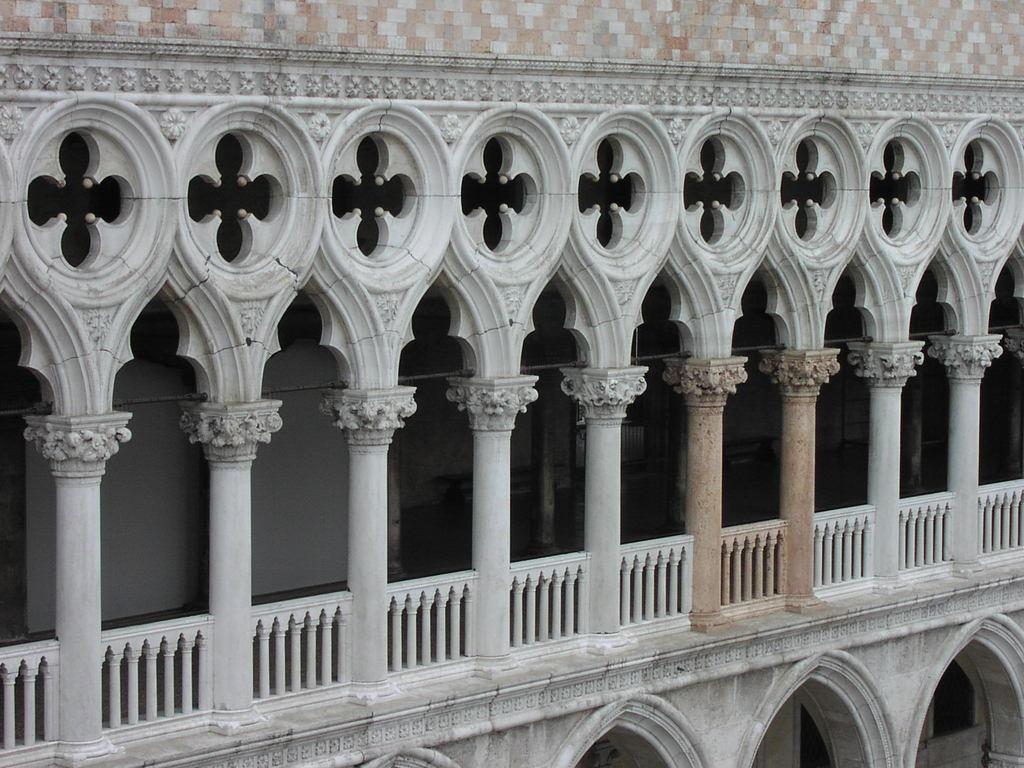What type of structure is present in the image? There is a building in the image. What colors can be seen on the building? The building is ash, brown, and white in color. What architectural features are visible on the building? There are pillars and railing visible in the image. Is there a spy exchanging information with an agent in the image? There is no indication of a spy or any exchange of information in the image; it features a building with pillars and railing. 